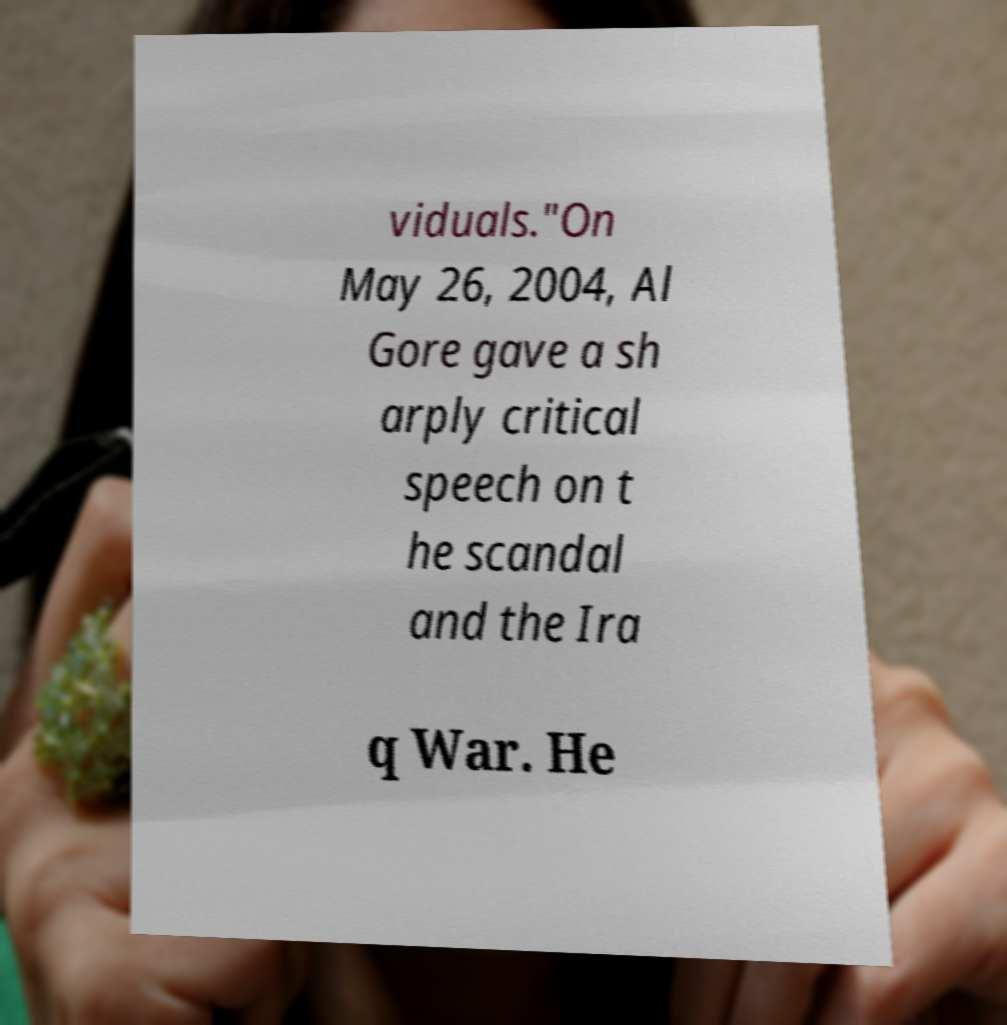Please identify and transcribe the text found in this image. viduals."On May 26, 2004, Al Gore gave a sh arply critical speech on t he scandal and the Ira q War. He 